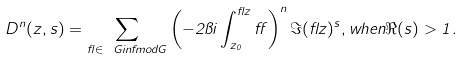Convert formula to latex. <formula><loc_0><loc_0><loc_500><loc_500>D ^ { n } ( z , s ) = \sum _ { \gamma \in \ G i n f m o d G } \left ( - 2 \pi i \int _ { z _ { 0 } } ^ { \gamma z } \alpha \right ) ^ { n } \Im ( \gamma z ) ^ { s } , w h e n \Re ( s ) > 1 .</formula> 